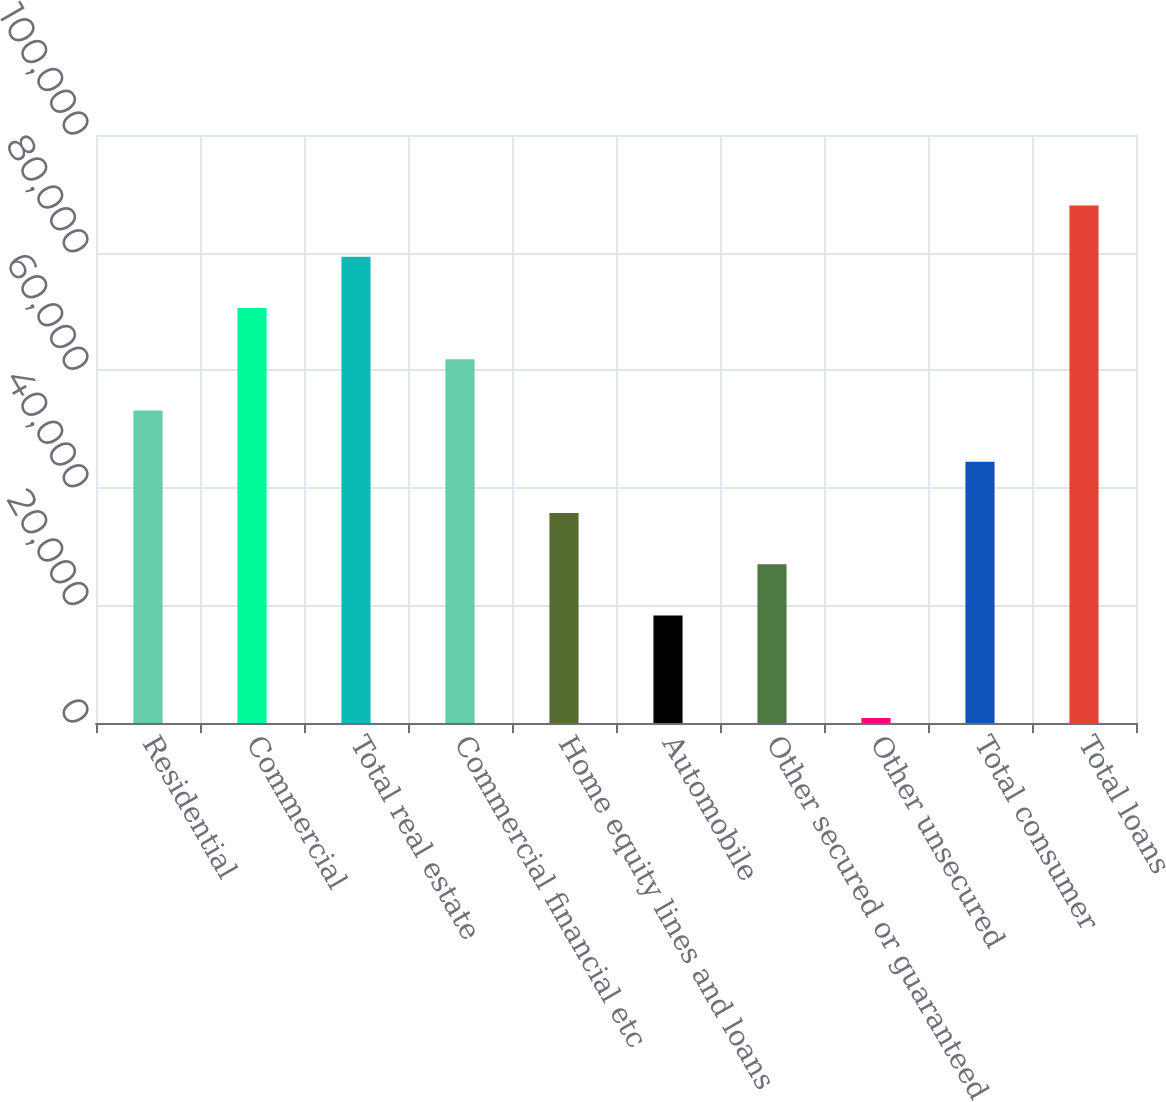<chart> <loc_0><loc_0><loc_500><loc_500><bar_chart><fcel>Residential<fcel>Commercial<fcel>Total real estate<fcel>Commercial financial etc<fcel>Home equity lines and loans<fcel>Automobile<fcel>Other secured or guaranteed<fcel>Other unsecured<fcel>Total consumer<fcel>Total loans<nl><fcel>53132.6<fcel>70560.8<fcel>79274.9<fcel>61846.7<fcel>35704.4<fcel>18276.2<fcel>26990.3<fcel>848<fcel>44418.5<fcel>87989<nl></chart> 